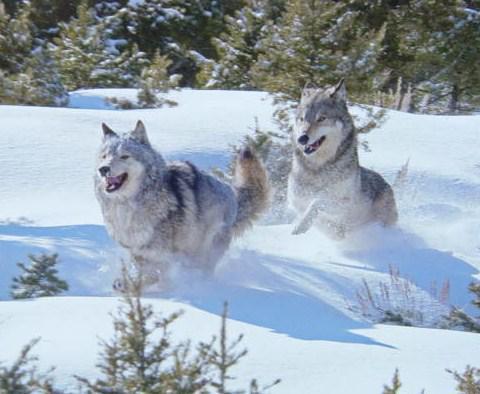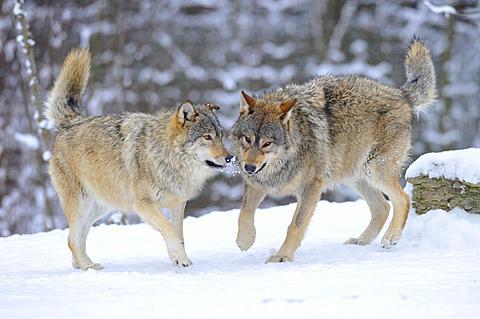The first image is the image on the left, the second image is the image on the right. Analyze the images presented: Is the assertion "An image shows exactly two different colored wolves interacting playfully in the snow, one with its rear toward the camera." valid? Answer yes or no. No. The first image is the image on the left, the second image is the image on the right. Assess this claim about the two images: "Two dogs are standing in the snow in the image on the right.". Correct or not? Answer yes or no. Yes. 